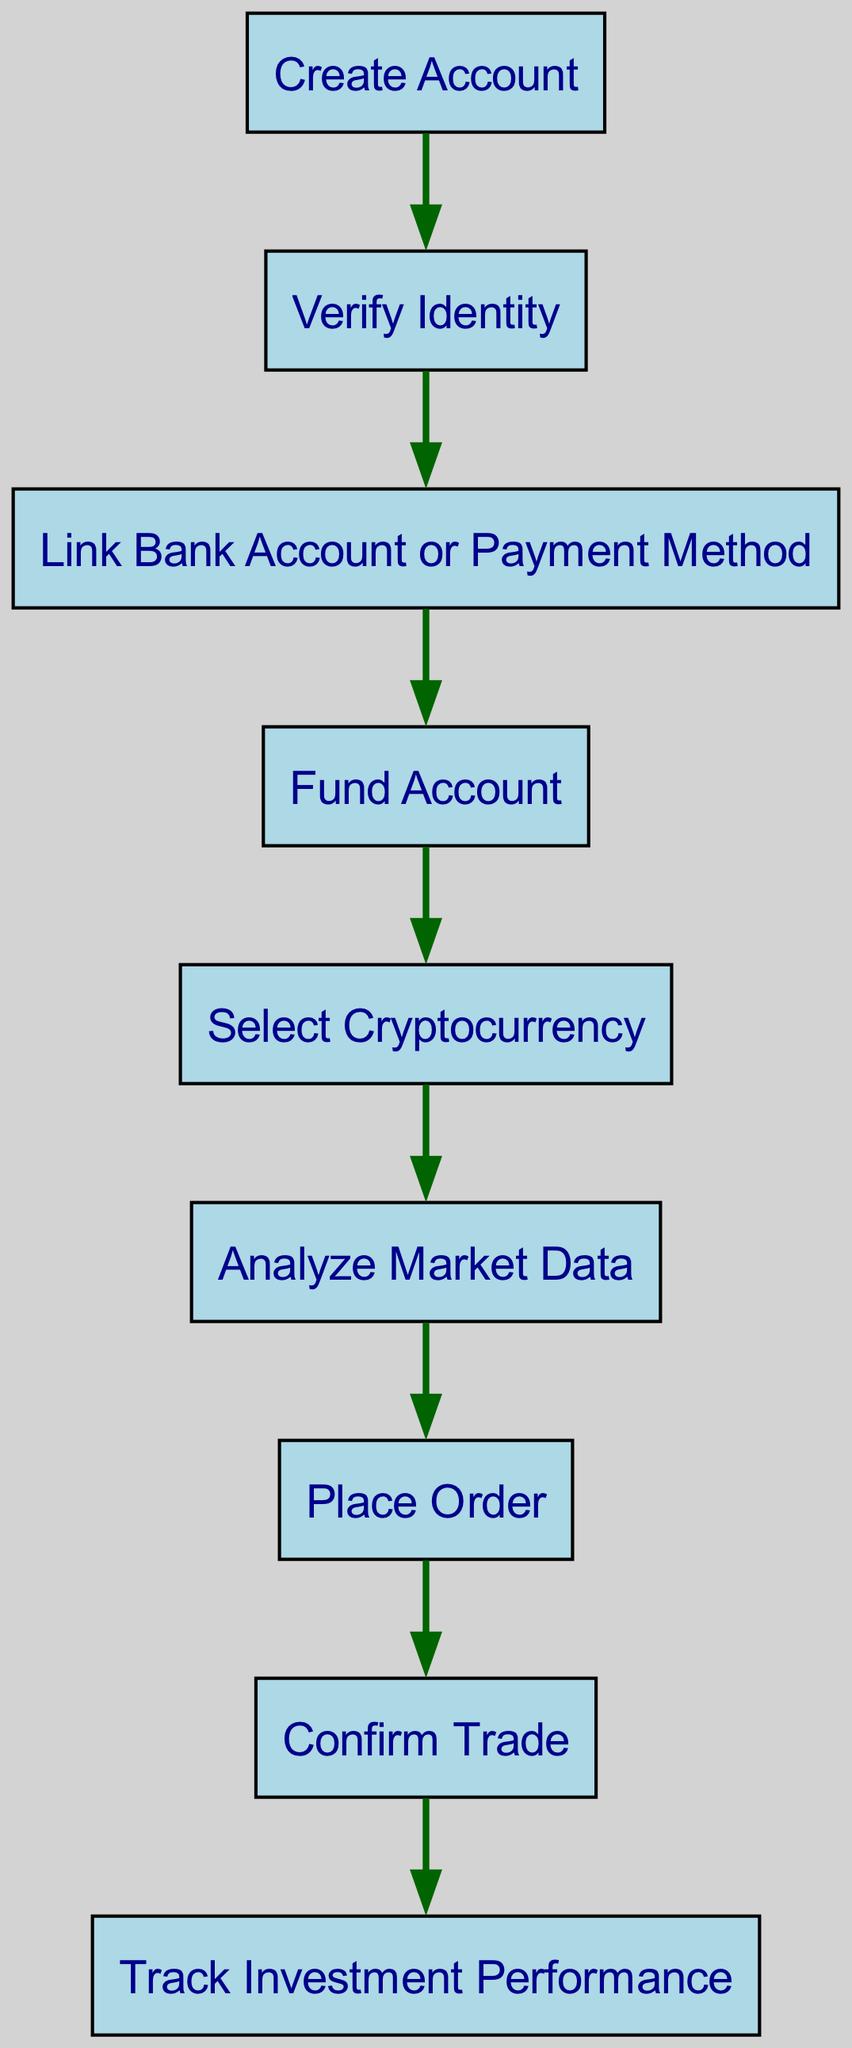What is the first step in the trading workflow? The first node in the diagram is "Create Account", indicating that this is the initial step in the cryptocurrency trading process.
Answer: Create Account How many nodes are there in the diagram? By counting the nodes listed, there are a total of 9 distinct steps in the workflow represented in the diagram.
Answer: 9 What directly follows "Verify Identity"? The edge from "Verify Identity" points to "Link Bank Account or Payment Method", showing that this step comes immediately after the identity verification process.
Answer: Link Bank Account or Payment Method Which step involves making an investment decision? The step "Analyze Market Data" indicates a critical moment where the trader evaluates market information to inform their investment strategy.
Answer: Analyze Market Data What is the final step after confirming a trade? The last node in the sequential flow is "Track Investment Performance", which is the concluding step performed after the trade has been confirmed.
Answer: Track Investment Performance What is the relationship between "Fund Account" and "Select Cryptocurrency"? There is a directed edge connecting "Fund Account" to "Select Cryptocurrency", indicating that one must fund their account before selecting the cryptocurrency to trade.
Answer: Link How many edges are in the diagram? By counting the connections (edges) established between nodes, there are 8 edges linking the various stages in the trading workflow.
Answer: 8 Which two steps are adjacent to "Place Order"? The node "Analyze Market Data" feeds into "Place Order" and "Place Order" connects to "Confirm Trade", indicating that these nodes are directly next to "Place Order".
Answer: Analyze Market Data, Confirm Trade What is the second step in the workflow? Following the flow of the nodes, the second step after "Create Account" is "Verify Identity", indicating the order of processes mandated by the workflow.
Answer: Verify Identity 